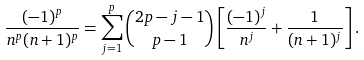<formula> <loc_0><loc_0><loc_500><loc_500>\frac { ( - 1 ) ^ { p } } { n ^ { p } ( n + 1 ) ^ { p } } = \sum _ { j = 1 } ^ { p } \binom { 2 p - j - 1 } { p - 1 } \left [ \frac { ( - 1 ) ^ { j } } { n ^ { j } } + \frac { 1 } { ( n + 1 ) ^ { j } } \right ] .</formula> 